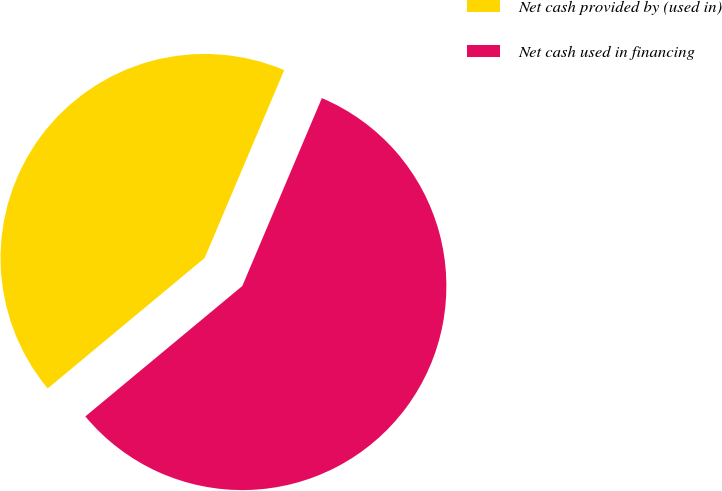Convert chart. <chart><loc_0><loc_0><loc_500><loc_500><pie_chart><fcel>Net cash provided by (used in)<fcel>Net cash used in financing<nl><fcel>42.41%<fcel>57.59%<nl></chart> 